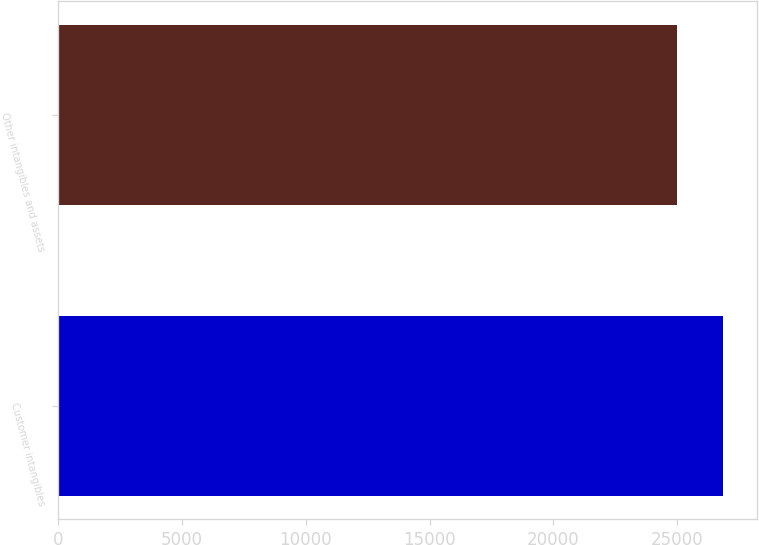<chart> <loc_0><loc_0><loc_500><loc_500><bar_chart><fcel>Customer intangibles<fcel>Other intangibles and assets<nl><fcel>26866<fcel>25000<nl></chart> 